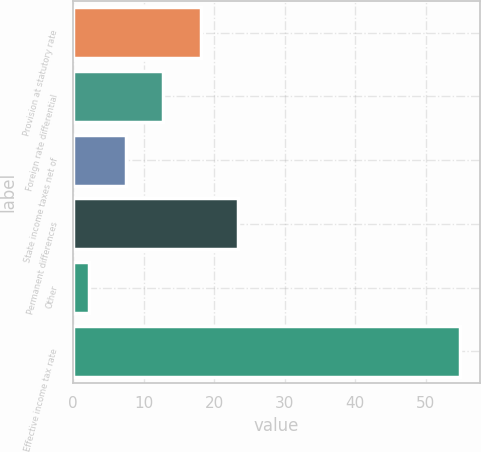Convert chart to OTSL. <chart><loc_0><loc_0><loc_500><loc_500><bar_chart><fcel>Provision at statutory rate<fcel>Foreign rate differential<fcel>State income taxes net of<fcel>Permanent differences<fcel>Other<fcel>Effective income tax rate<nl><fcel>18.08<fcel>12.82<fcel>7.56<fcel>23.34<fcel>2.3<fcel>54.9<nl></chart> 